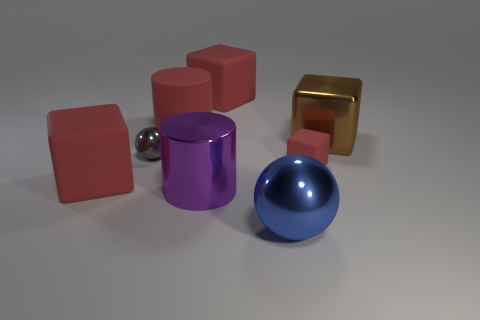Subtract all blue balls. How many red cubes are left? 3 Subtract 1 blocks. How many blocks are left? 3 Add 1 red objects. How many objects exist? 9 Subtract all cylinders. How many objects are left? 6 Add 4 large brown things. How many large brown things exist? 5 Subtract 0 cyan blocks. How many objects are left? 8 Subtract all large blue things. Subtract all metallic things. How many objects are left? 3 Add 1 tiny red matte objects. How many tiny red matte objects are left? 2 